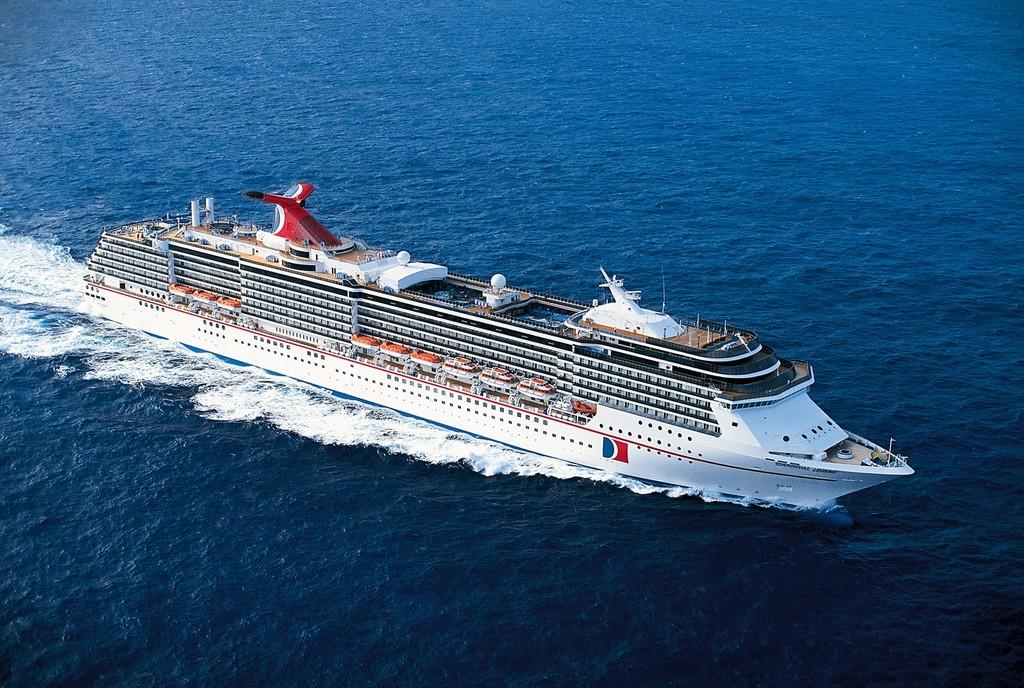What type of vehicle is in the image? There is a white cruise in the image. Where is the cruise located? The cruise is on the water. What type of slip is the cruise using to stay afloat in the image? There is no mention of a slip in the image, and the cruise is already on the water. How many pies are being served on the cruise in the image? There is no information about pies or any food being served on the cruise in the image. 